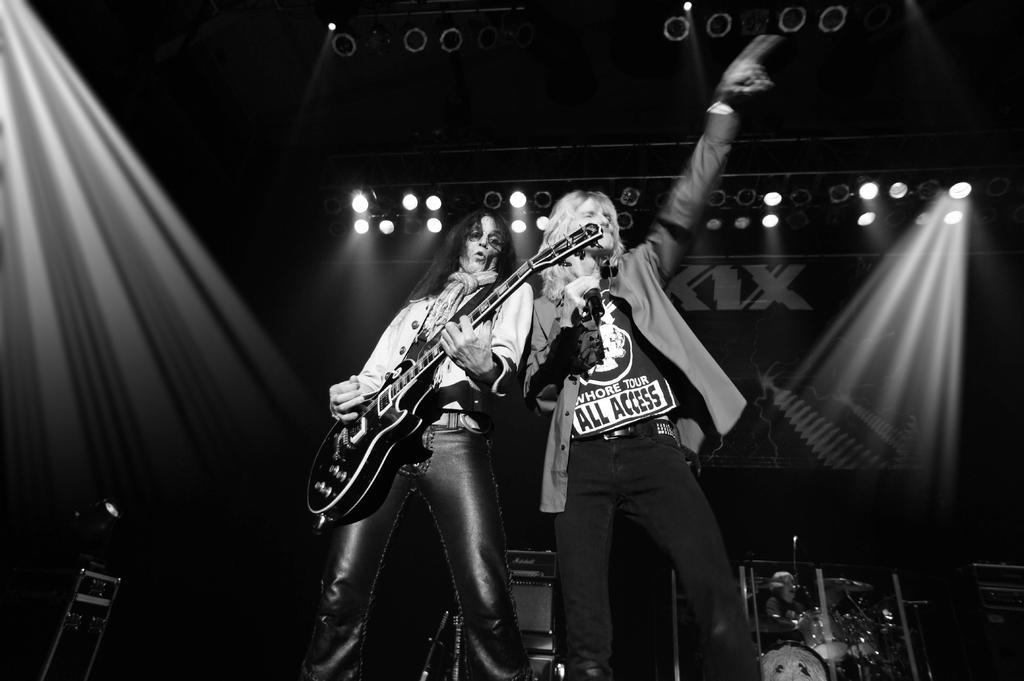Describe this image in one or two sentences. A black and white picture. This woman is playing guitar and this man is singing in-front of mic. On top there are focusing lights. 